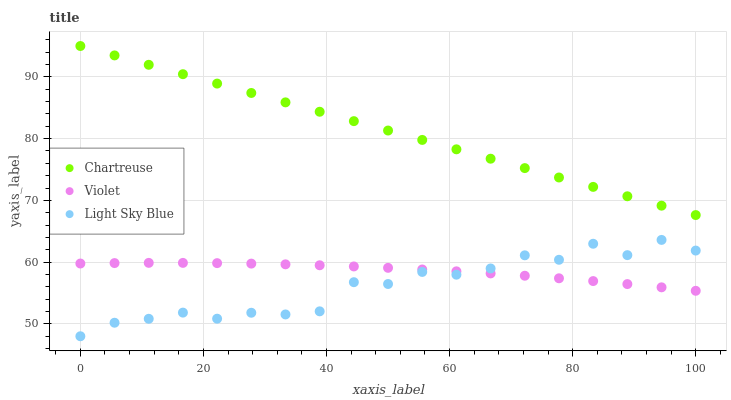Does Light Sky Blue have the minimum area under the curve?
Answer yes or no. Yes. Does Chartreuse have the maximum area under the curve?
Answer yes or no. Yes. Does Violet have the minimum area under the curve?
Answer yes or no. No. Does Violet have the maximum area under the curve?
Answer yes or no. No. Is Chartreuse the smoothest?
Answer yes or no. Yes. Is Light Sky Blue the roughest?
Answer yes or no. Yes. Is Violet the smoothest?
Answer yes or no. No. Is Violet the roughest?
Answer yes or no. No. Does Light Sky Blue have the lowest value?
Answer yes or no. Yes. Does Violet have the lowest value?
Answer yes or no. No. Does Chartreuse have the highest value?
Answer yes or no. Yes. Does Light Sky Blue have the highest value?
Answer yes or no. No. Is Light Sky Blue less than Chartreuse?
Answer yes or no. Yes. Is Chartreuse greater than Violet?
Answer yes or no. Yes. Does Violet intersect Light Sky Blue?
Answer yes or no. Yes. Is Violet less than Light Sky Blue?
Answer yes or no. No. Is Violet greater than Light Sky Blue?
Answer yes or no. No. Does Light Sky Blue intersect Chartreuse?
Answer yes or no. No. 